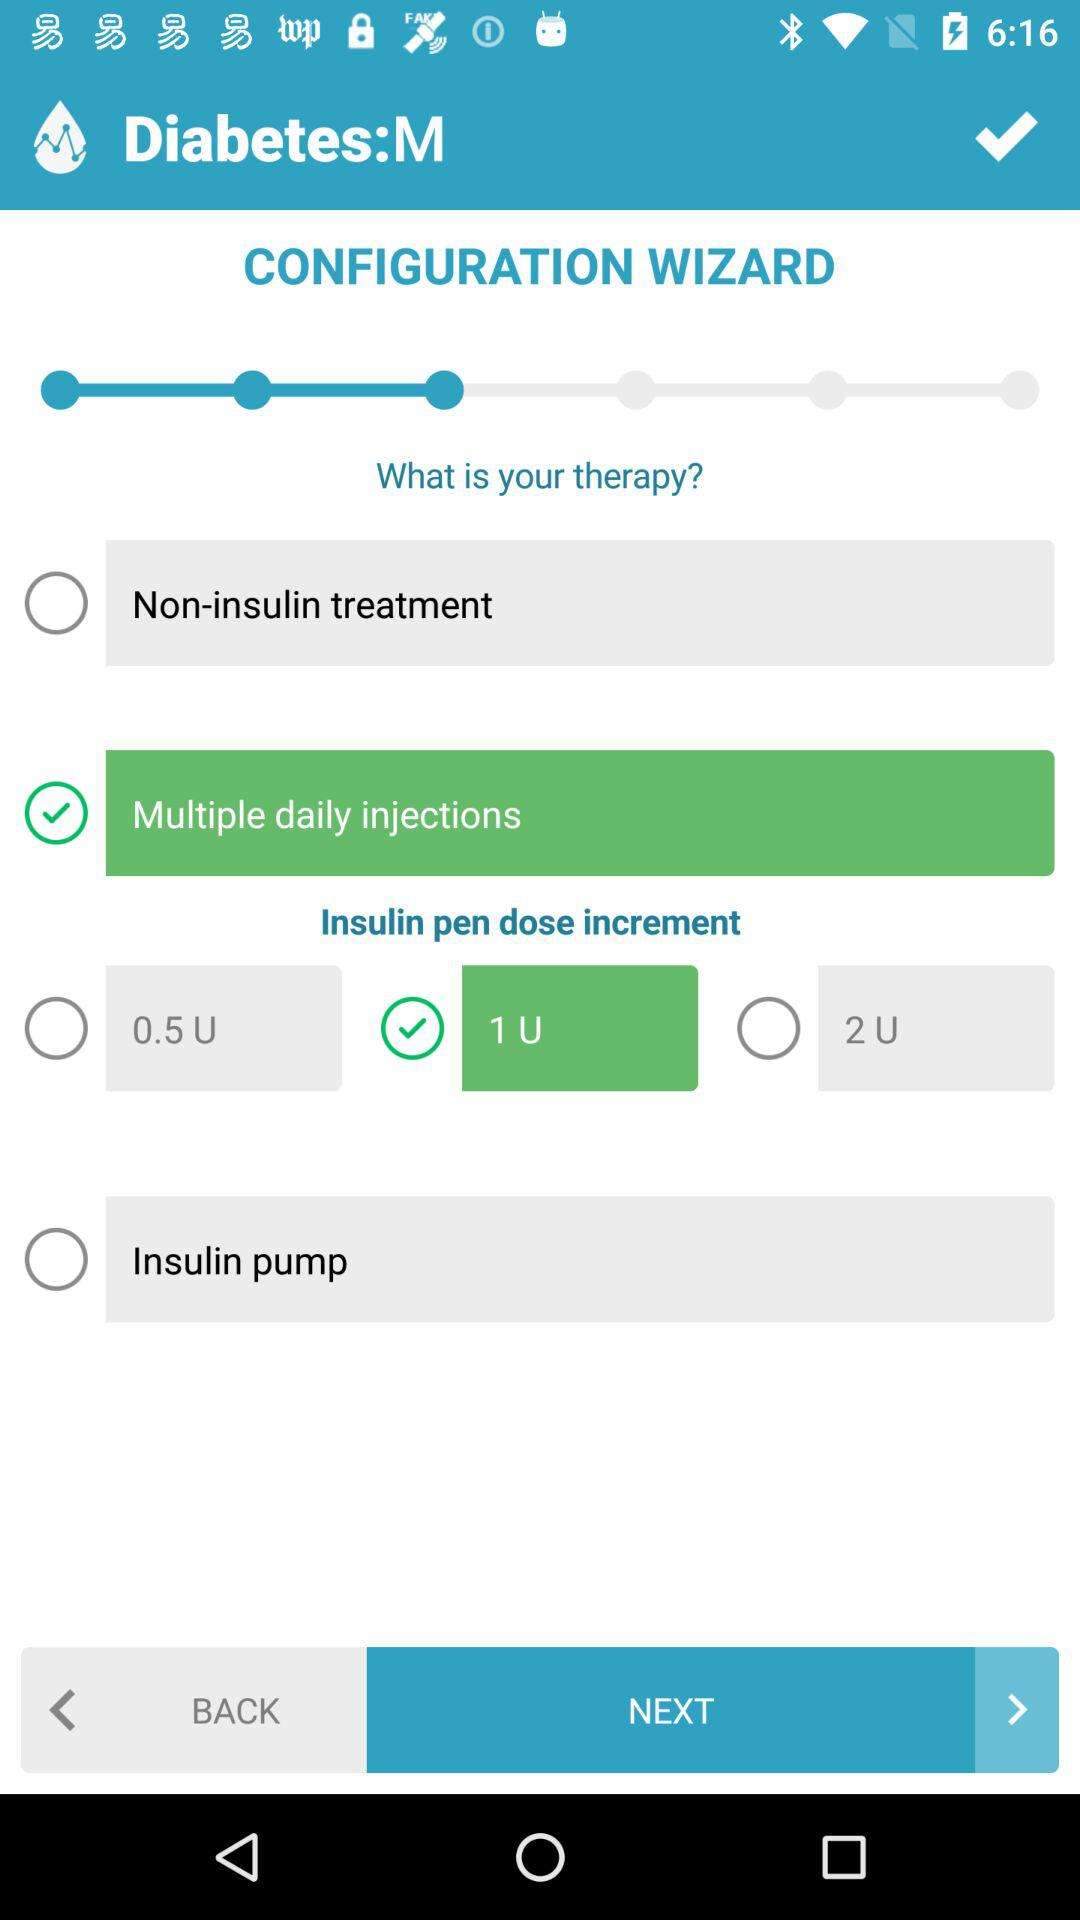How many insulin pen dose increments are available?
Answer the question using a single word or phrase. 3 